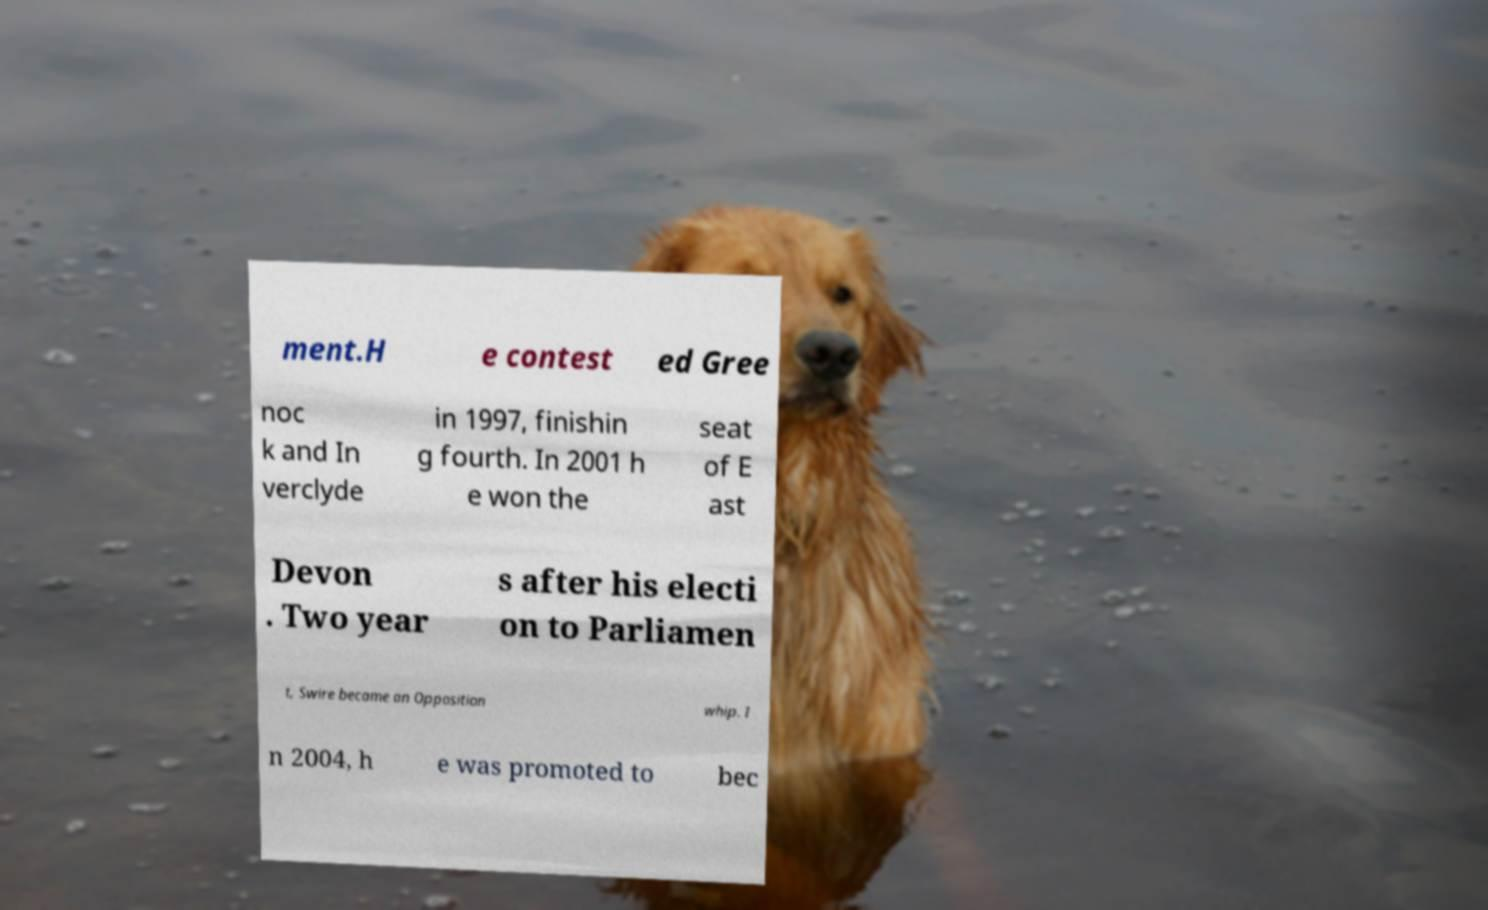Could you extract and type out the text from this image? ment.H e contest ed Gree noc k and In verclyde in 1997, finishin g fourth. In 2001 h e won the seat of E ast Devon . Two year s after his electi on to Parliamen t, Swire became an Opposition whip. I n 2004, h e was promoted to bec 